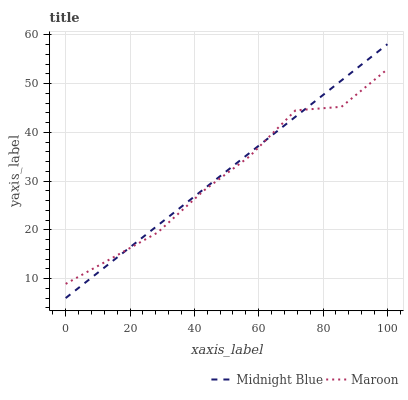Does Maroon have the minimum area under the curve?
Answer yes or no. Yes. Does Midnight Blue have the maximum area under the curve?
Answer yes or no. Yes. Does Maroon have the maximum area under the curve?
Answer yes or no. No. Is Midnight Blue the smoothest?
Answer yes or no. Yes. Is Maroon the roughest?
Answer yes or no. Yes. Is Maroon the smoothest?
Answer yes or no. No. Does Maroon have the lowest value?
Answer yes or no. No. Does Midnight Blue have the highest value?
Answer yes or no. Yes. Does Maroon have the highest value?
Answer yes or no. No. 